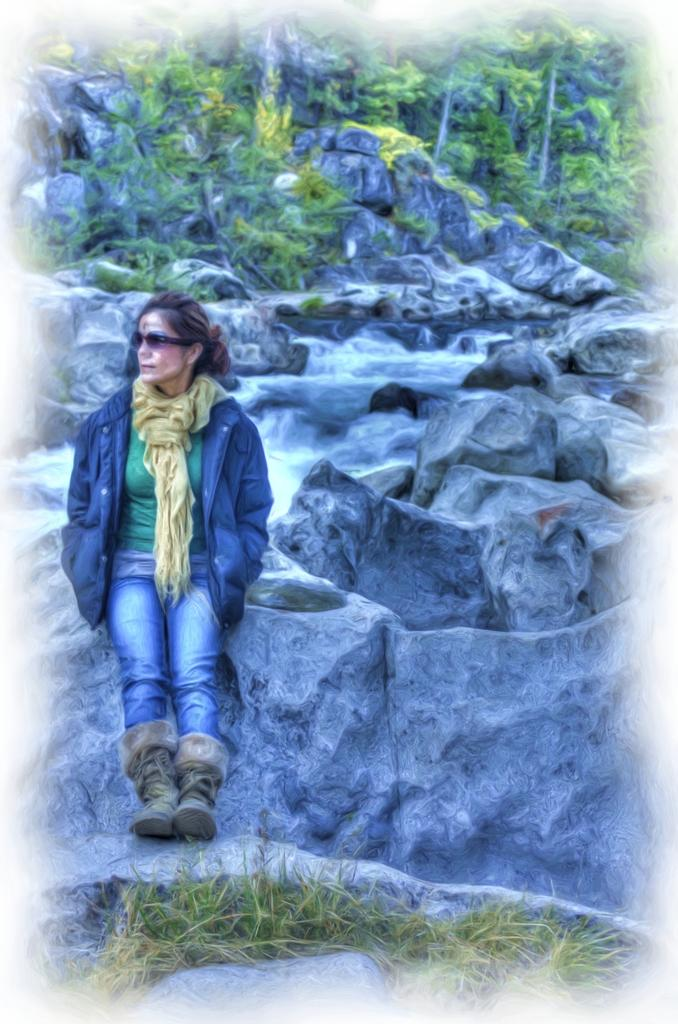What is the lady in the image sitting on? The lady is sitting on stones in the image. What type of vegetation is visible at the bottom of the image? There is grass at the bottom of the image. What is happening with the water in the image? Water is flowing on stones in the image. What is the price of the bucket in the image? There is no bucket present in the image, so it is not possible to determine its price. 